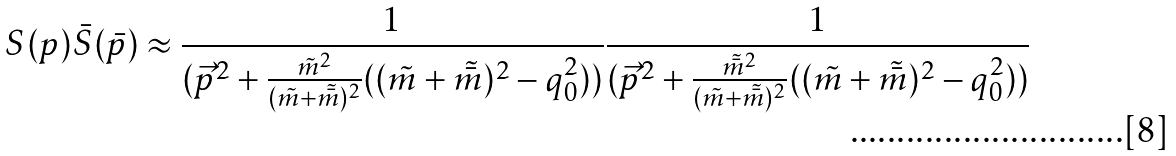Convert formula to latex. <formula><loc_0><loc_0><loc_500><loc_500>S ( p ) \bar { S } ( \bar { p } ) \approx \frac { 1 } { ( \vec { p } ^ { 2 } + \frac { \tilde { m } ^ { 2 } } { ( \tilde { m } + \tilde { \bar { m } } ) ^ { 2 } } ( ( \tilde { m } + \tilde { \bar { m } } ) ^ { 2 } - q _ { 0 } ^ { 2 } ) ) } \frac { 1 } { ( \vec { p } ^ { 2 } + \frac { \tilde { \bar { m } } ^ { 2 } } { ( \tilde { m } + \tilde { \bar { m } } ) ^ { 2 } } ( ( \tilde { m } + \tilde { \bar { m } } ) ^ { 2 } - q _ { 0 } ^ { 2 } ) ) }</formula> 